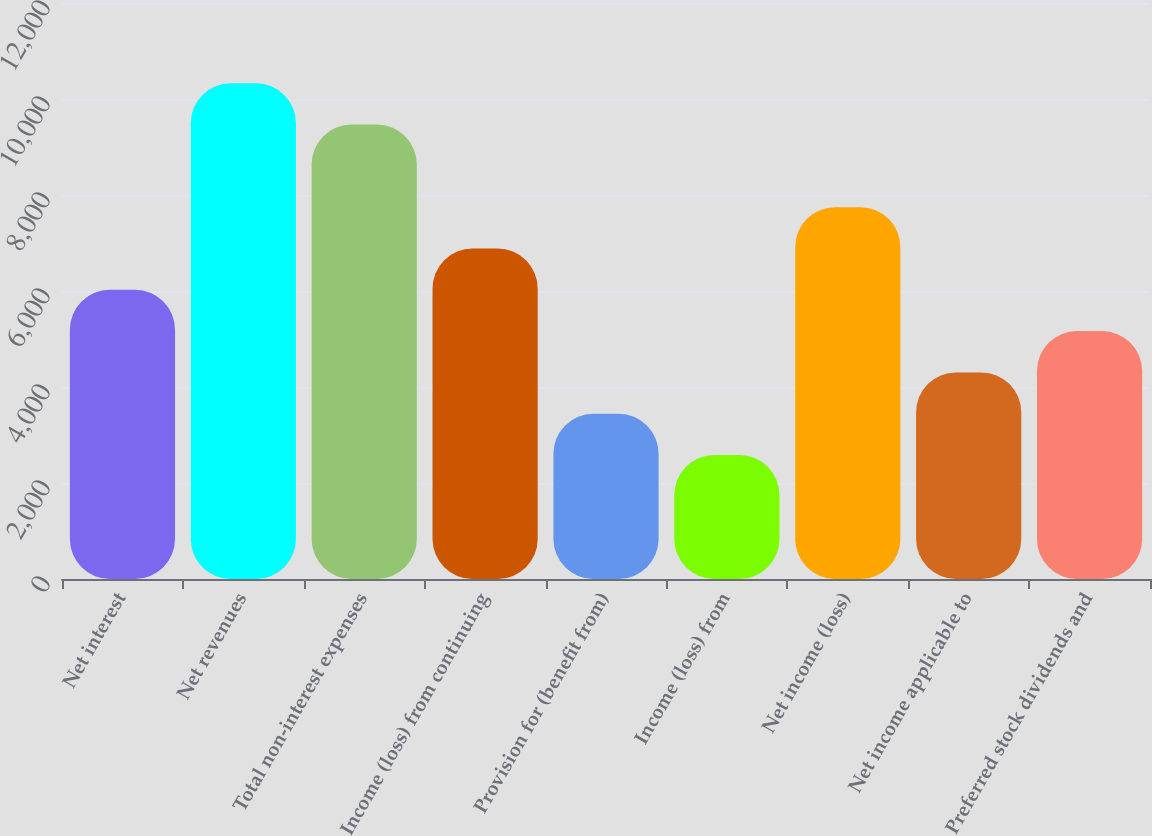Convert chart. <chart><loc_0><loc_0><loc_500><loc_500><bar_chart><fcel>Net interest<fcel>Net revenues<fcel>Total non-interest expenses<fcel>Income (loss) from continuing<fcel>Provision for (benefit from)<fcel>Income (loss) from<fcel>Net income (loss)<fcel>Net income applicable to<fcel>Preferred stock dividends and<nl><fcel>6025.63<fcel>10329.6<fcel>9468.79<fcel>6886.42<fcel>3443.26<fcel>2582.47<fcel>7747.21<fcel>4304.05<fcel>5164.84<nl></chart> 